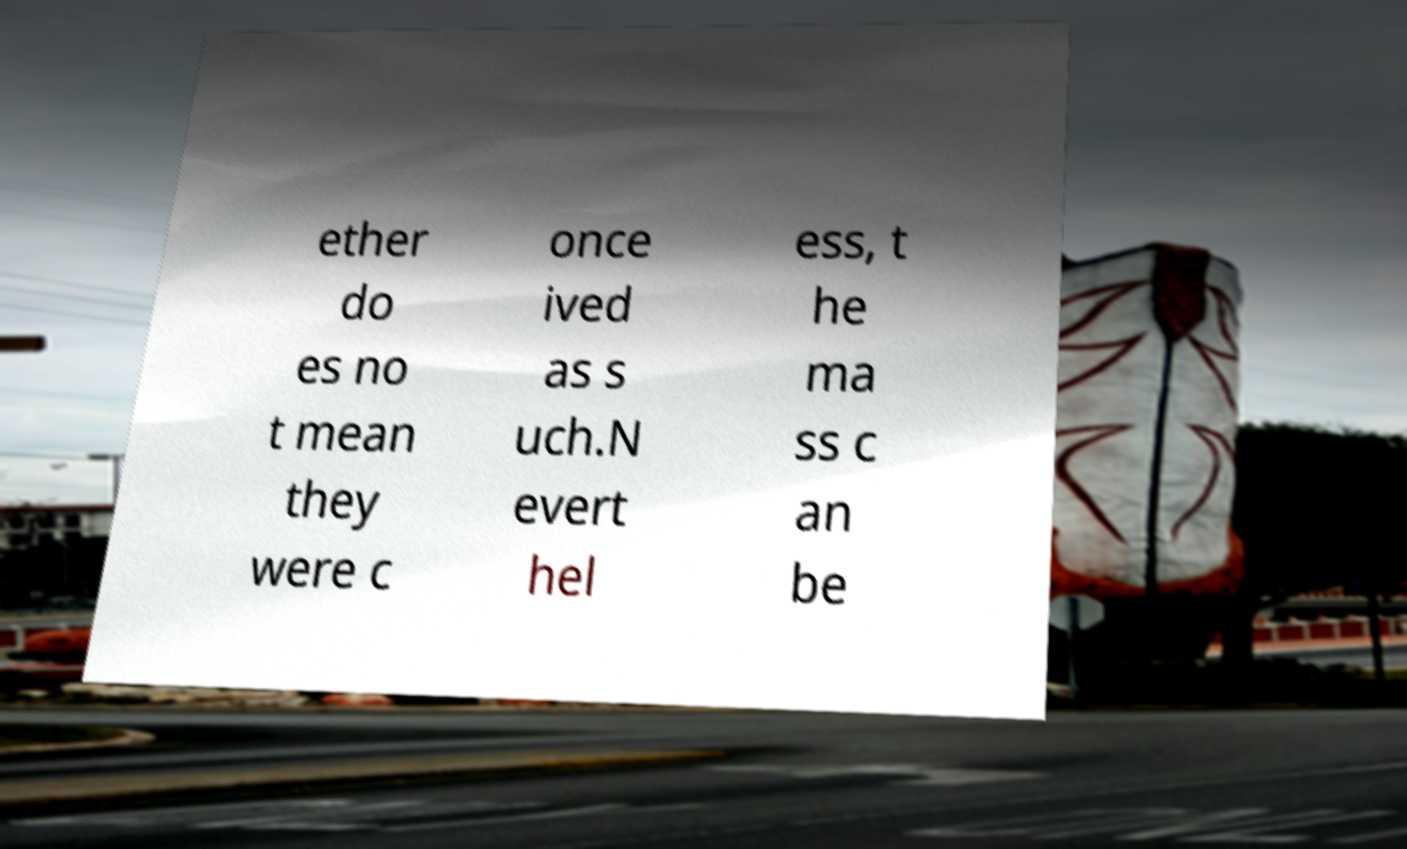What messages or text are displayed in this image? I need them in a readable, typed format. ether do es no t mean they were c once ived as s uch.N evert hel ess, t he ma ss c an be 